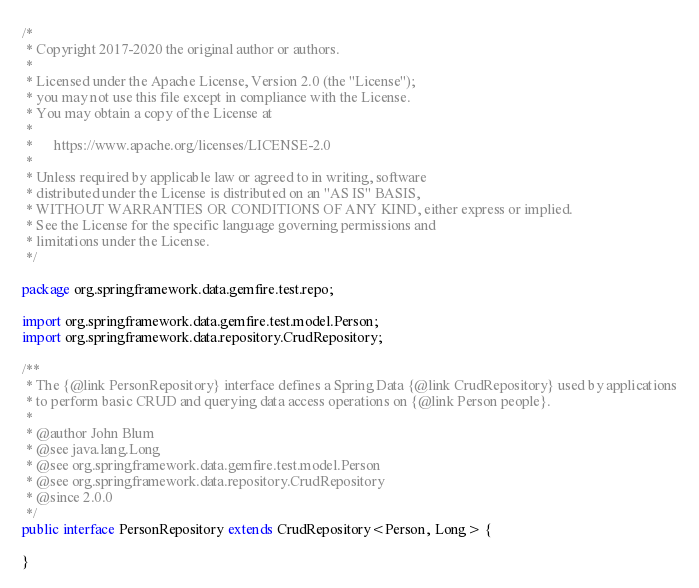Convert code to text. <code><loc_0><loc_0><loc_500><loc_500><_Java_>/*
 * Copyright 2017-2020 the original author or authors.
 *
 * Licensed under the Apache License, Version 2.0 (the "License");
 * you may not use this file except in compliance with the License.
 * You may obtain a copy of the License at
 *
 *      https://www.apache.org/licenses/LICENSE-2.0
 *
 * Unless required by applicable law or agreed to in writing, software
 * distributed under the License is distributed on an "AS IS" BASIS,
 * WITHOUT WARRANTIES OR CONDITIONS OF ANY KIND, either express or implied.
 * See the License for the specific language governing permissions and
 * limitations under the License.
 */

package org.springframework.data.gemfire.test.repo;

import org.springframework.data.gemfire.test.model.Person;
import org.springframework.data.repository.CrudRepository;

/**
 * The {@link PersonRepository} interface defines a Spring Data {@link CrudRepository} used by applications
 * to perform basic CRUD and querying data access operations on {@link Person people}.
 *
 * @author John Blum
 * @see java.lang.Long
 * @see org.springframework.data.gemfire.test.model.Person
 * @see org.springframework.data.repository.CrudRepository
 * @since 2.0.0
 */
public interface PersonRepository extends CrudRepository<Person, Long> {

}
</code> 